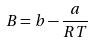Convert formula to latex. <formula><loc_0><loc_0><loc_500><loc_500>B = b - \frac { a } { R T }</formula> 